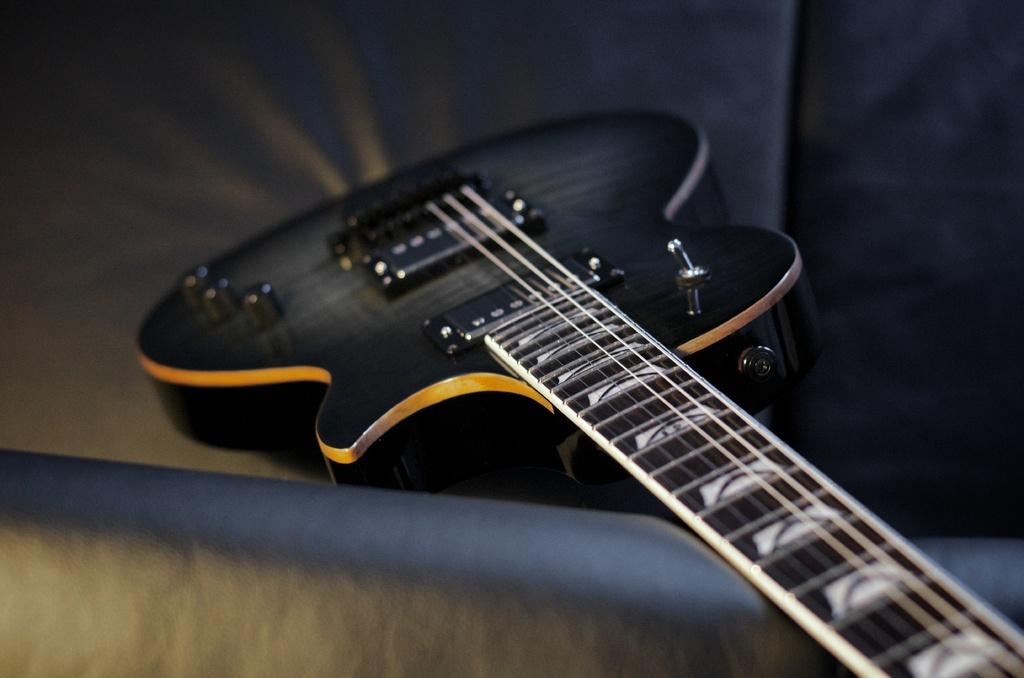What type of musical instrument is in the image? There is a black guitar in the image. How is the guitar described in the image? The guitar is described as beautiful. Where is the guitar located in the image? The guitar is in the middle of the image. Can you see the receipt for the guitar purchase in the image? There is no receipt visible in the image. Is there a snake wrapped around the guitar in the image? There is no snake present in the image. 